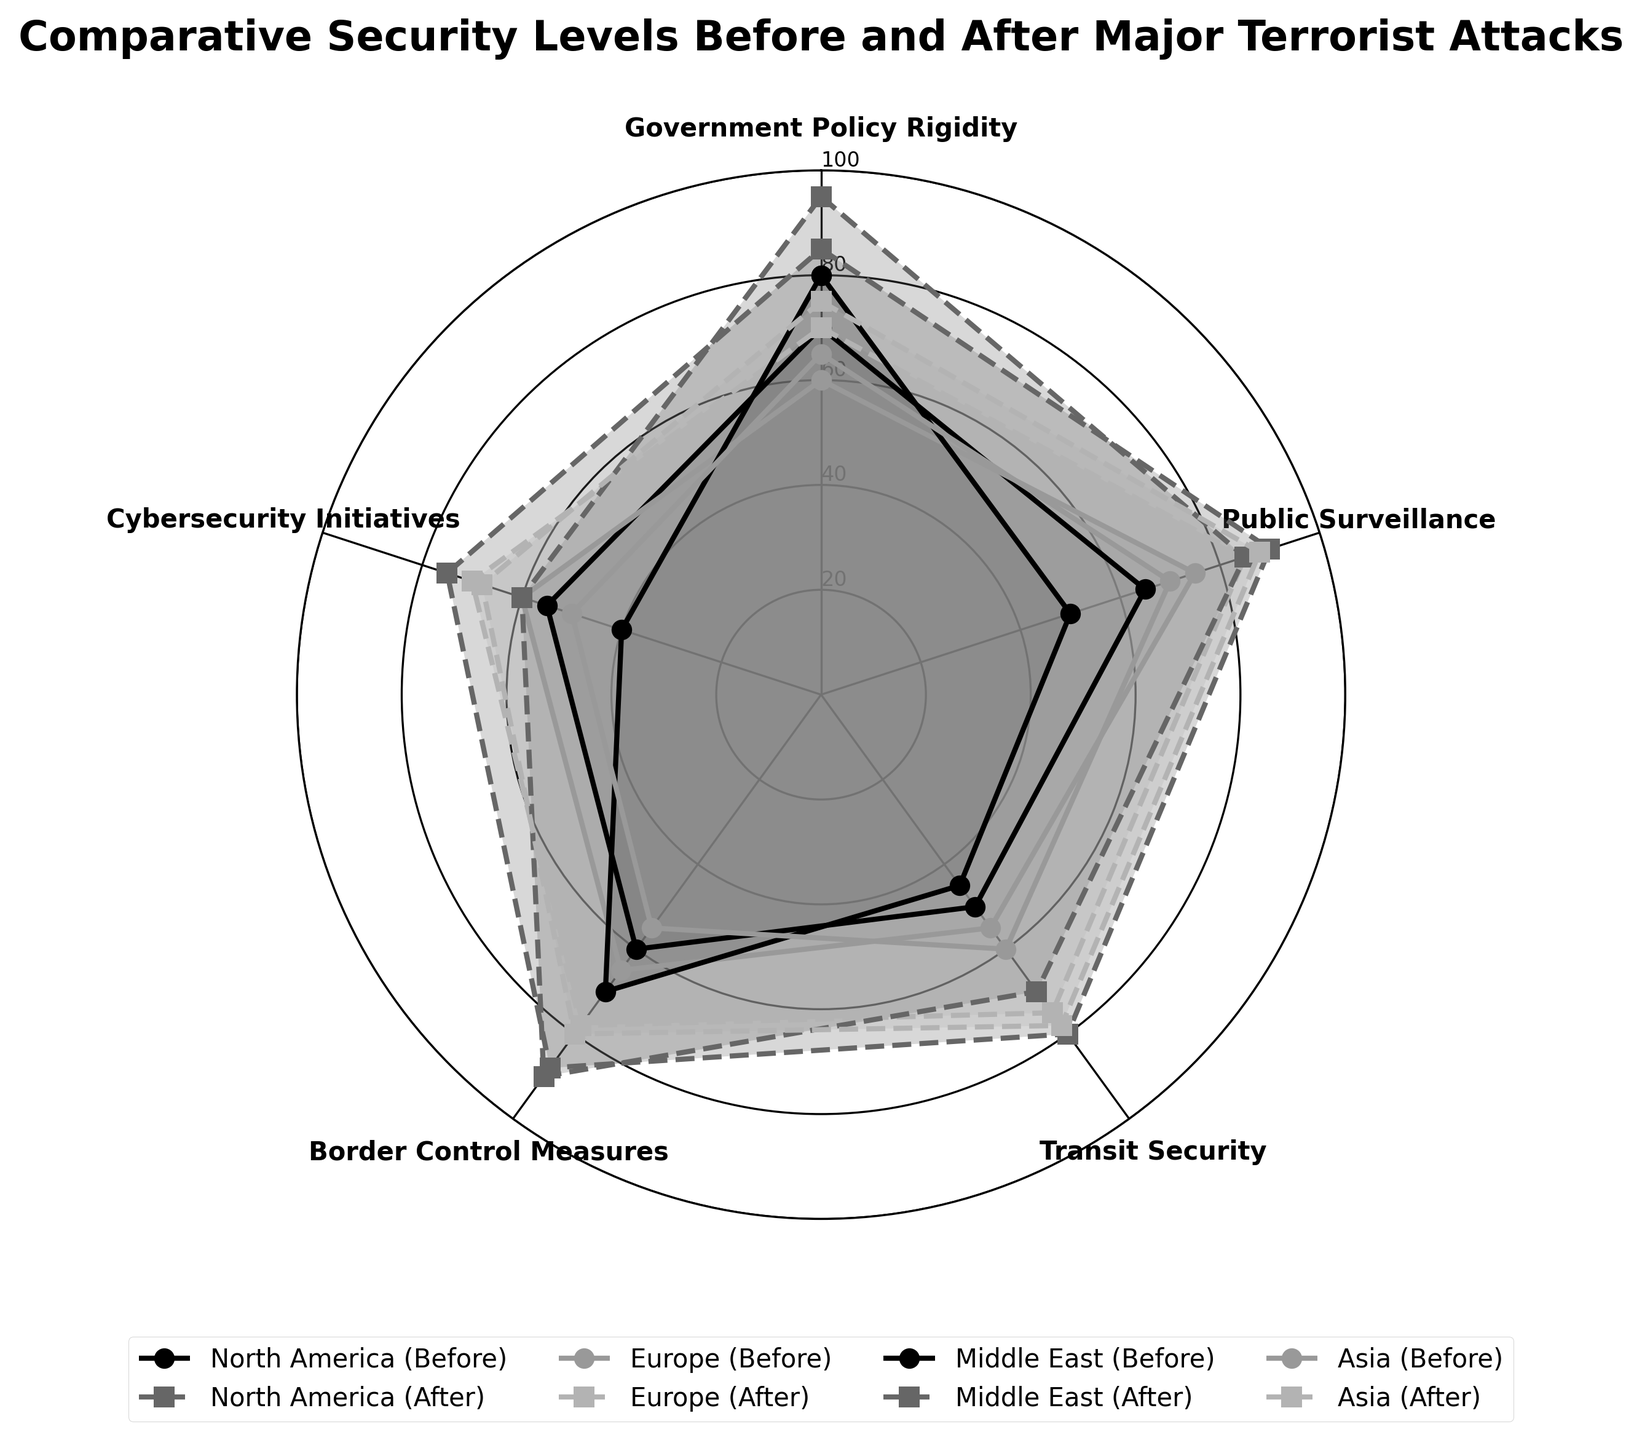Which region had the highest increase in Public Surveillance after the attack? North America went from 65 to 90, Europe from 75 to 85, the Middle East from 50 to 85, and Asia from 70 to 88. The increase for North America is 25, for Europe is 10, for the Middle East is 35, and for Asia is 18. The Middle East has the highest increase.
Answer: The Middle East Which region showed the smallest difference in Government Policy Rigidity before and after the attack? North America increased from 70 to 85 (difference of 15), Europe from 60 to 70 (difference of 10), the Middle East from 80 to 95 (difference of 15), and Asia from 65 to 75 (difference of 10). The smallest differences are 10 for both Europe and Asia.
Answer: Europe and Asia What is the average increase in Cybersecurity Initiatives across all regions? North America increased from 55 to 75 (increase of 20), Europe from 60 to 70 (increase of 10), the Middle East from 40 to 60 (increase of 20), and Asia from 50 to 68 (increase of 18). The average increase is (20 + 10 + 20 + 18) / 4 = 17.
Answer: 17 Which region had the lowest level of Transit Security before the attack? North America had 50, Europe 55, the Middle East 45, and Asia 60. The Middle East had the lowest level of Transit Security before the attack.
Answer: The Middle East Comparing the levels of Border Control Measures, in which region was the increase the least significant? North America’s increase is 28 (60 to 88), Europe’s increase is 13 (65 to 78), the Middle East’s increase is 20 (70 to 90), and Asia’s increase is 25 (55 to 80). Europe had the least significant increase.
Answer: Europe 